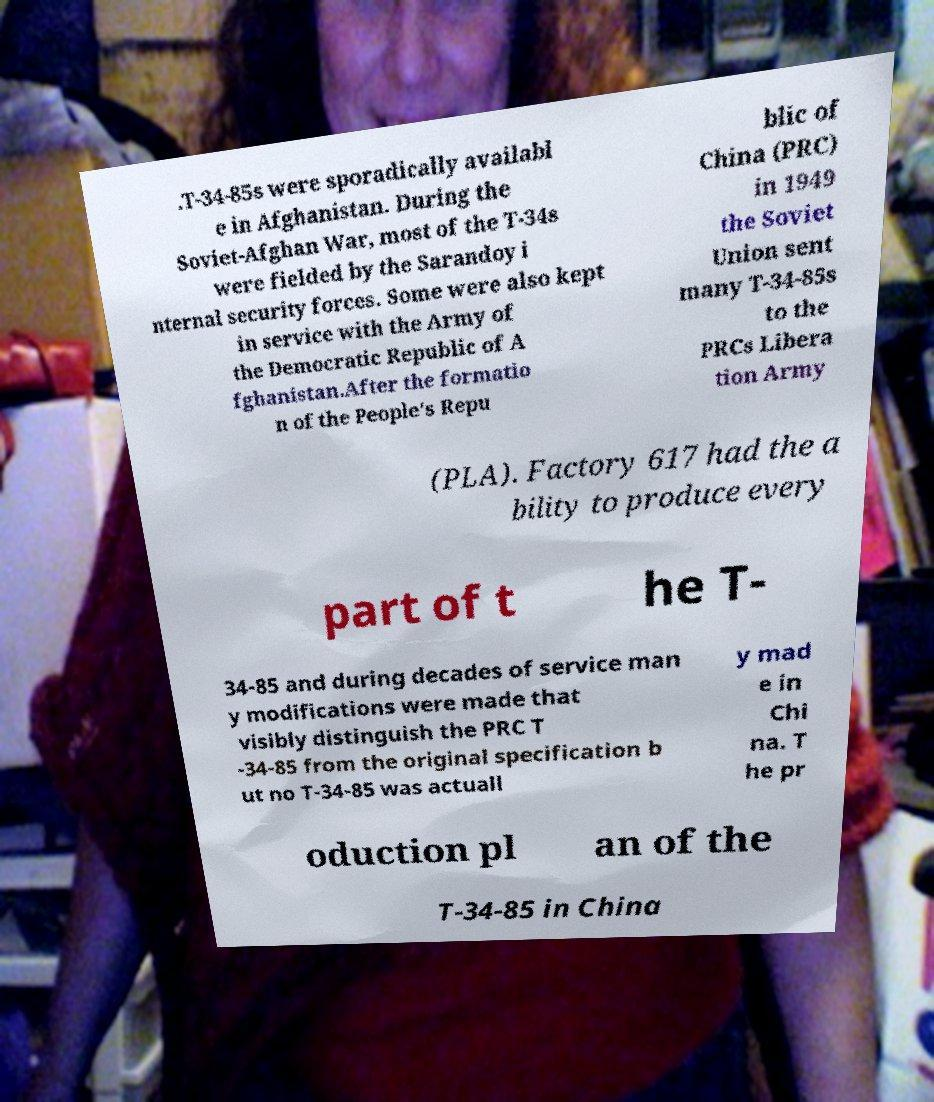Please read and relay the text visible in this image. What does it say? .T-34-85s were sporadically availabl e in Afghanistan. During the Soviet-Afghan War, most of the T-34s were fielded by the Sarandoy i nternal security forces. Some were also kept in service with the Army of the Democratic Republic of A fghanistan.After the formatio n of the People's Repu blic of China (PRC) in 1949 the Soviet Union sent many T-34-85s to the PRCs Libera tion Army (PLA). Factory 617 had the a bility to produce every part of t he T- 34-85 and during decades of service man y modifications were made that visibly distinguish the PRC T -34-85 from the original specification b ut no T-34-85 was actuall y mad e in Chi na. T he pr oduction pl an of the T-34-85 in China 